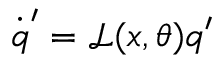<formula> <loc_0><loc_0><loc_500><loc_500>\dot { q } ^ { \prime } = \mathcal { L } ( x , \theta ) q ^ { \prime }</formula> 